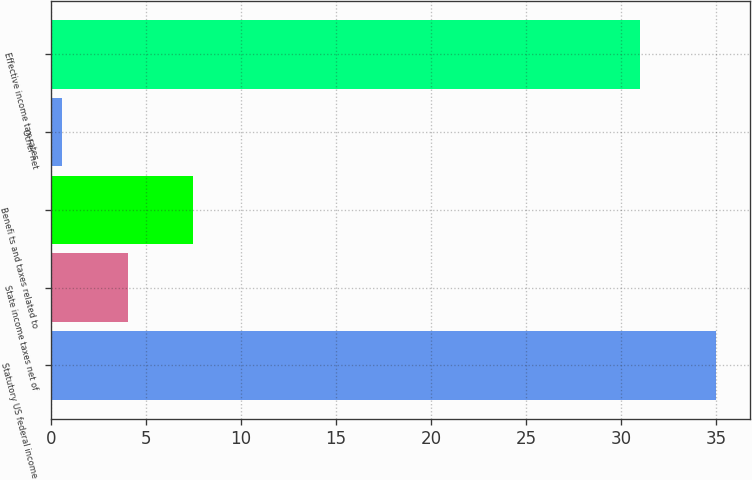<chart> <loc_0><loc_0><loc_500><loc_500><bar_chart><fcel>Statutory US federal income<fcel>State income taxes net of<fcel>Benefi ts and taxes related to<fcel>Other net<fcel>Effective income tax rates<nl><fcel>35<fcel>4.04<fcel>7.48<fcel>0.6<fcel>31<nl></chart> 